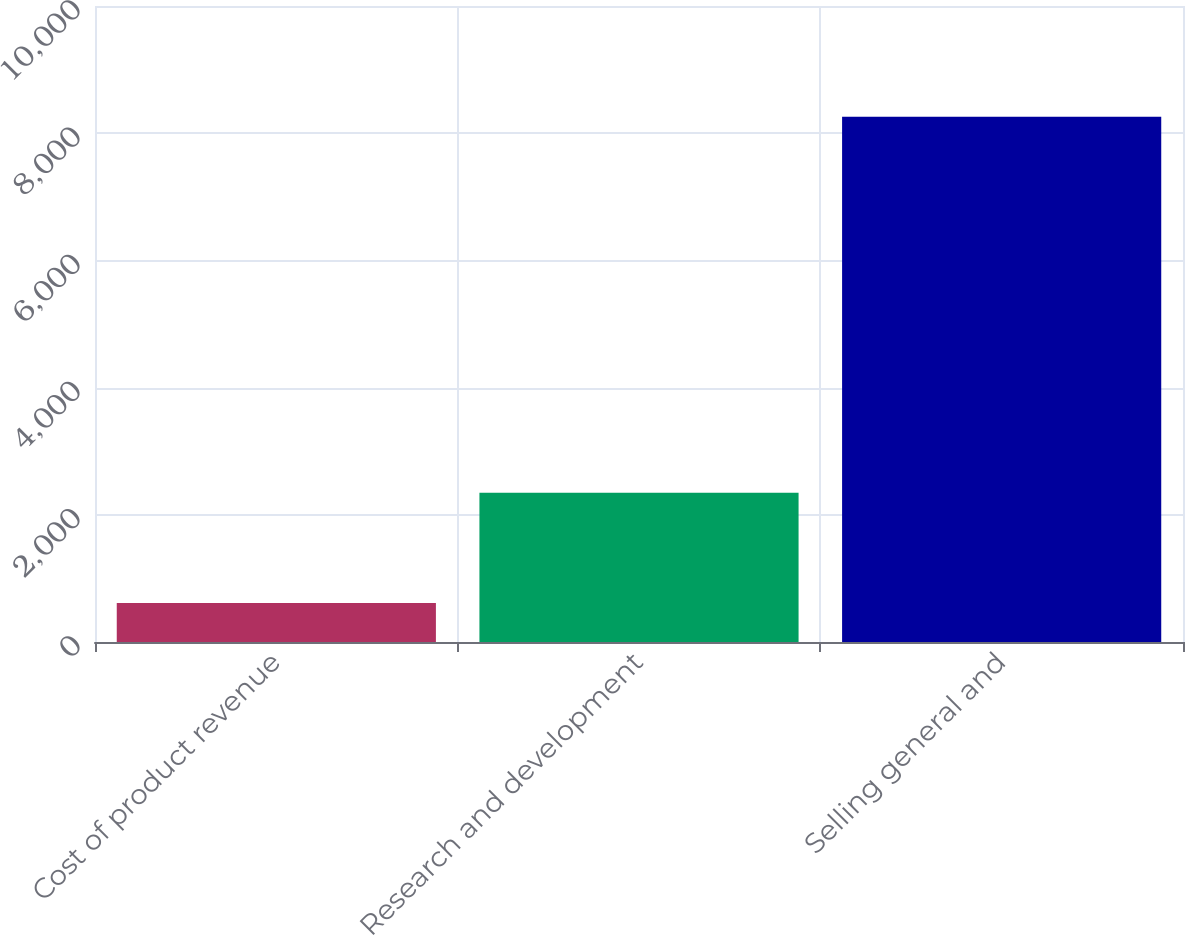<chart> <loc_0><loc_0><loc_500><loc_500><bar_chart><fcel>Cost of product revenue<fcel>Research and development<fcel>Selling general and<nl><fcel>614<fcel>2347<fcel>8257<nl></chart> 